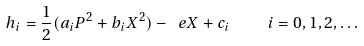<formula> <loc_0><loc_0><loc_500><loc_500>h _ { i } = \frac { 1 } { 2 } ( a _ { i } P ^ { 2 } + b _ { i } X ^ { 2 } ) - \ e X + c _ { i } \quad i = 0 , 1 , 2 , \dots</formula> 